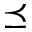Convert formula to latex. <formula><loc_0><loc_0><loc_500><loc_500>\preceq</formula> 